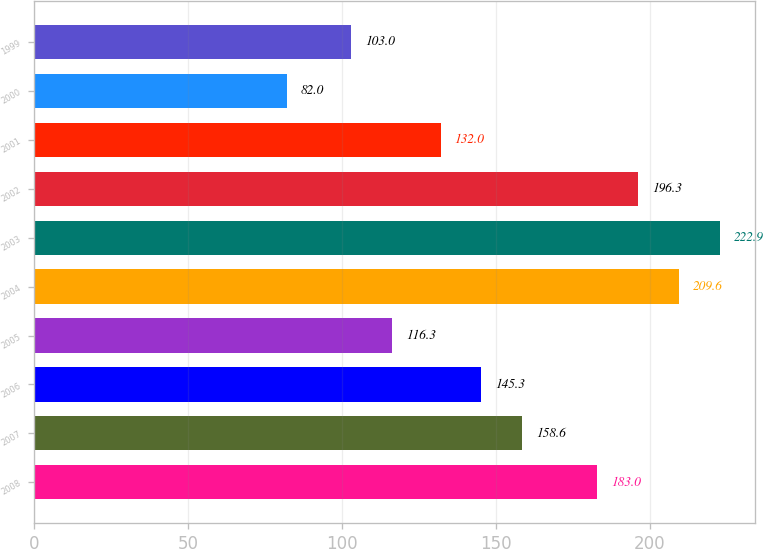<chart> <loc_0><loc_0><loc_500><loc_500><bar_chart><fcel>2008<fcel>2007<fcel>2006<fcel>2005<fcel>2004<fcel>2003<fcel>2002<fcel>2001<fcel>2000<fcel>1999<nl><fcel>183<fcel>158.6<fcel>145.3<fcel>116.3<fcel>209.6<fcel>222.9<fcel>196.3<fcel>132<fcel>82<fcel>103<nl></chart> 